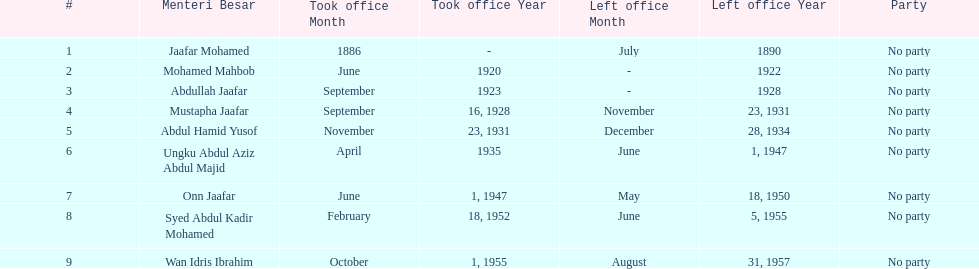Who took office after abdullah jaafar? Mustapha Jaafar. 